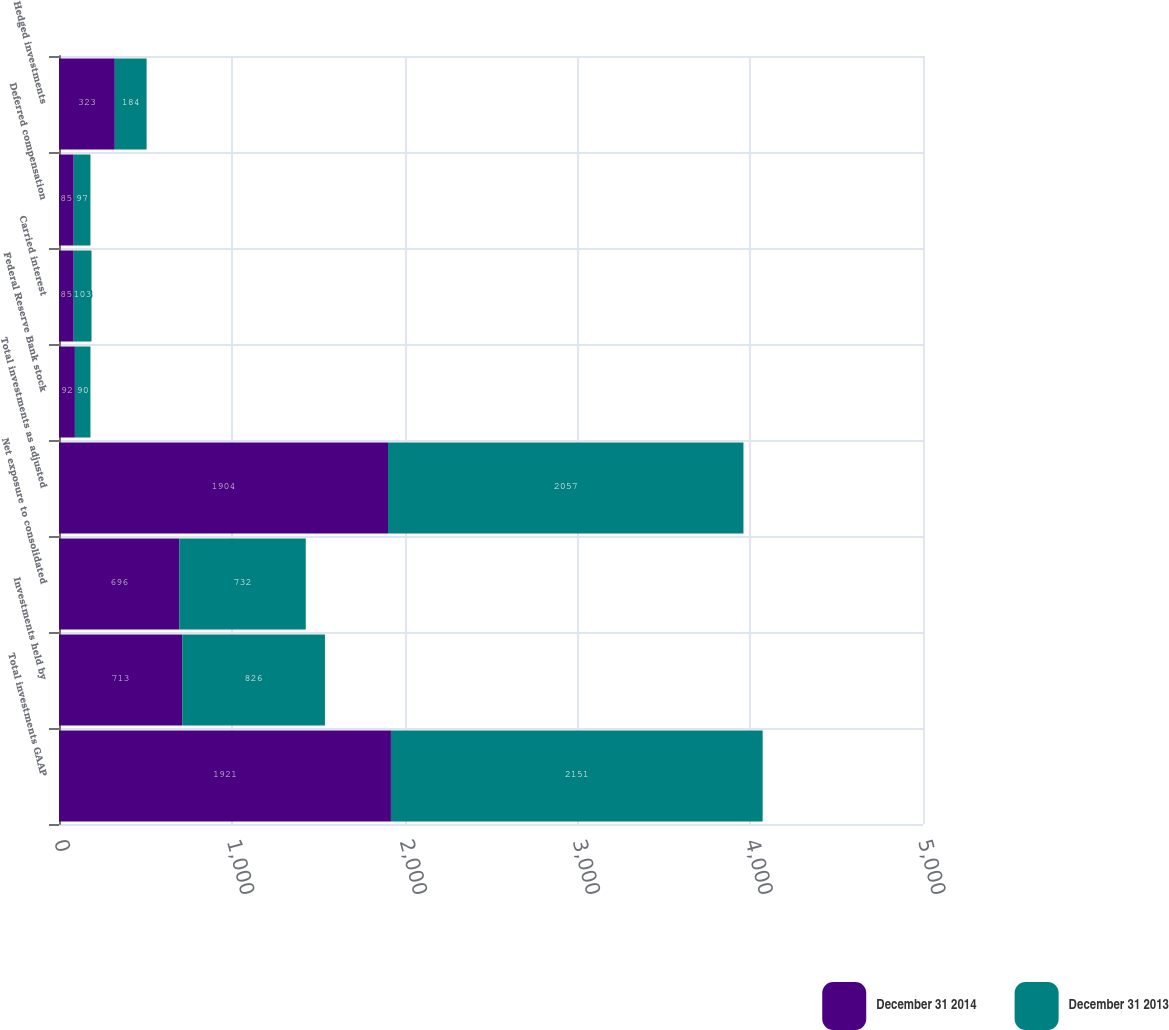Convert chart to OTSL. <chart><loc_0><loc_0><loc_500><loc_500><stacked_bar_chart><ecel><fcel>Total investments GAAP<fcel>Investments held by<fcel>Net exposure to consolidated<fcel>Total investments as adjusted<fcel>Federal Reserve Bank stock<fcel>Carried interest<fcel>Deferred compensation<fcel>Hedged investments<nl><fcel>December 31 2014<fcel>1921<fcel>713<fcel>696<fcel>1904<fcel>92<fcel>85<fcel>85<fcel>323<nl><fcel>December 31 2013<fcel>2151<fcel>826<fcel>732<fcel>2057<fcel>90<fcel>103<fcel>97<fcel>184<nl></chart> 